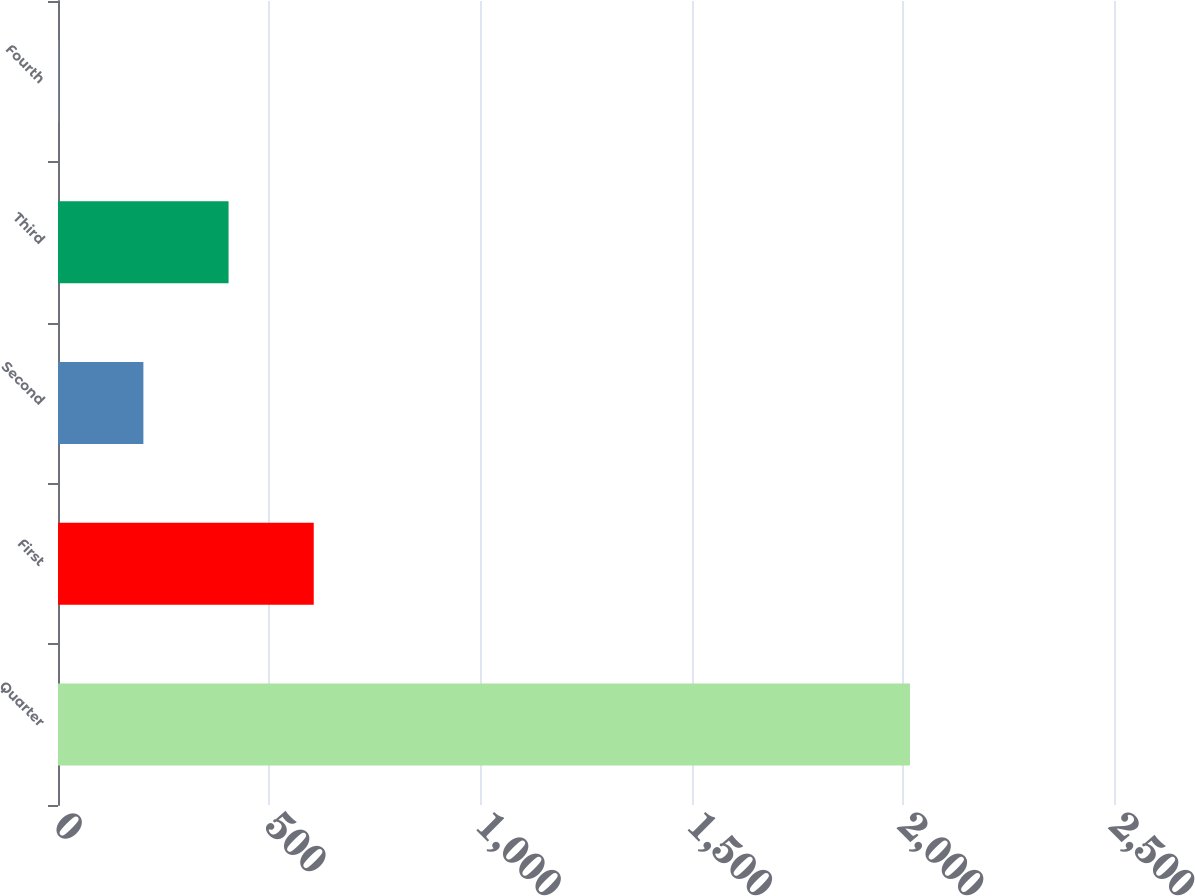<chart> <loc_0><loc_0><loc_500><loc_500><bar_chart><fcel>Quarter<fcel>First<fcel>Second<fcel>Third<fcel>Fourth<nl><fcel>2017<fcel>605.46<fcel>202.16<fcel>403.81<fcel>0.51<nl></chart> 